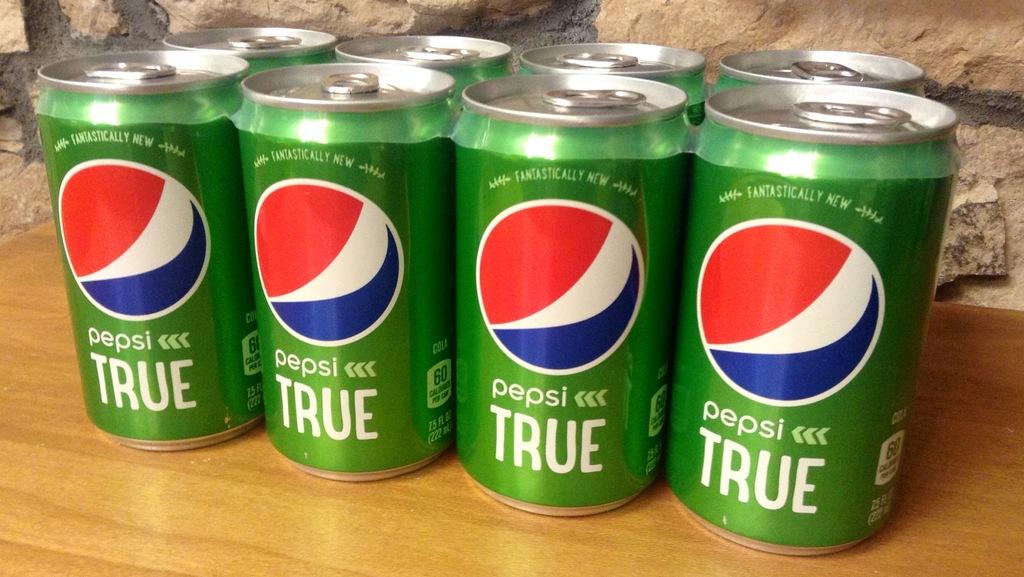What pepsi is that?
Make the answer very short. True. What brand are those sodas?
Your answer should be very brief. Pepsi. 